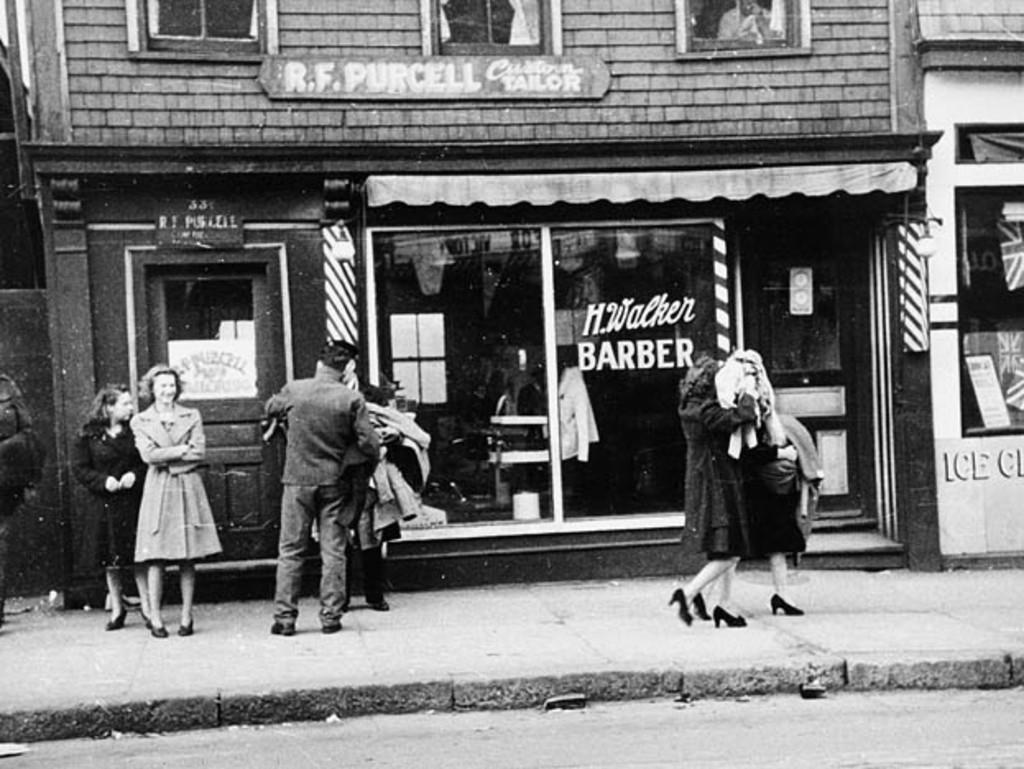What type of pictures are in the image? The image contains black and white pictures. What is the main structure in the image? There is a building in the image. What is happening in front of the building? There are people in front of the building. What architectural features can be seen on the building? There are windows visible in the building. What other objects are present in the image? There are boards and a door visible in the image. What is the opinion of the oranges about the way the building is constructed? There are no oranges present in the image, and therefore their opinion cannot be determined. 